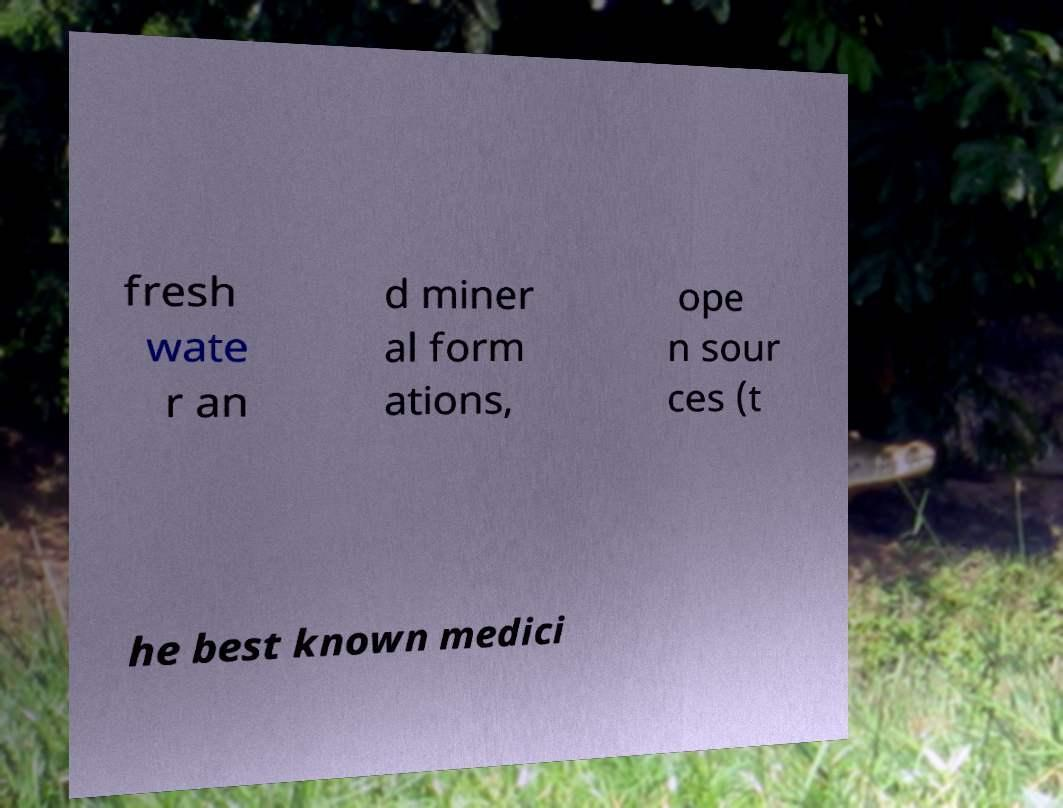For documentation purposes, I need the text within this image transcribed. Could you provide that? fresh wate r an d miner al form ations, ope n sour ces (t he best known medici 